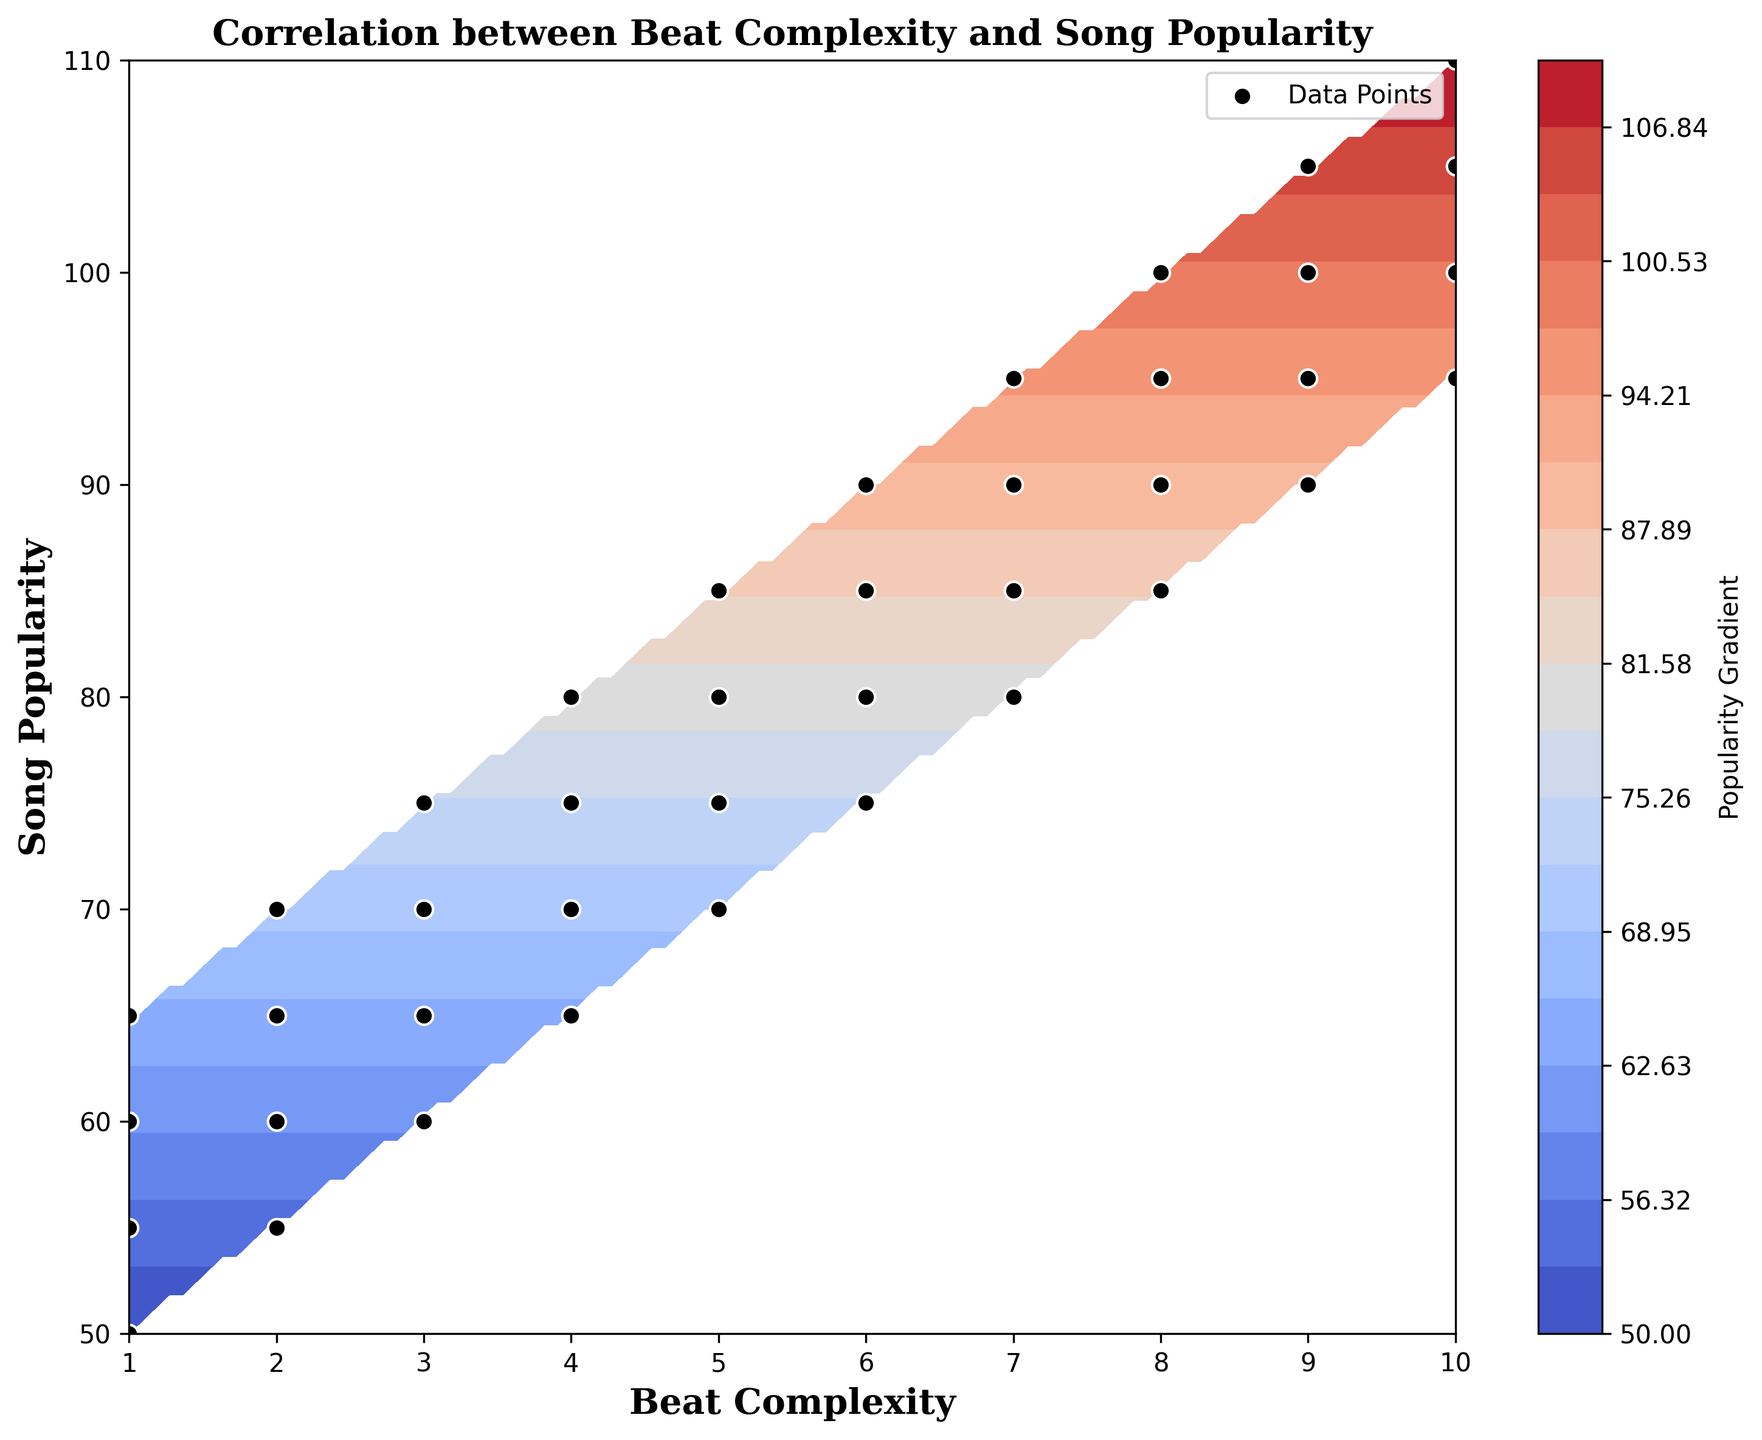What trend do you observe between beat complexity and song popularity? The contour plots show a clear gradient where as beat complexity increases, the song popularity also tends to increase. This indicates a positive correlation.
Answer: Positive correlation Where are the highest levels of song popularity found on the plot? The highest levels of song popularity, indicated by the darkest shades in the contour plot, are found at high beat complexity values, specifically around 9 and 10.
Answer: Around beat complexity of 9 and 10 Which beat complexity range exhibits the largest gradient change in song popularity? The largest gradient change in song popularity is observed between beat complexity of 8 and 10, where there is a steep shift in popularity scores.
Answer: Between beat complexity of 8 and 10 What is the beat complexity level at the lowest popularity range? The lowest popularity, around 50, is at the beat complexity level of 1.
Answer: Beat complexity of 1 Compare the popularity of songs with a beat complexity of 3 to those with a beat complexity of 6. Songs with a beat complexity of 3 have popularity ranging from 60 to 75, whereas those with a beat complexity of 6 range from 75 to 90. Thus, higher beat complexity has higher popularity.
Answer: Beat complexity of 6 is higher At which beat complexity does the song popularity start to exceed 80? Song popularity starts to exceed 80 at a beat complexity level of 7.
Answer: Beat complexity of 7 Are there any beat complexity levels where song popularity shows a dip? There is no observable dip in the song popularity across any beat complexity levels; the trend consistently increases.
Answer: No dips What does the color gradient indicate about the relationship between beat complexity and popularity? The color gradient, shifting from lighter to darker hues, indicates that as beat complexity increases, the song popularity tends to rise. The darker areas represent higher popularity.
Answer: Higher beat complexity, higher popularity Which beat complexity levels have data points representing the highest recorded popularity? Data points showing the highest recorded popularity are found at beat complexity levels of 8, 9, and 10.
Answer: Beat complexity 8, 9, 10 What can you say about the distribution of song popularity for beat complexity 5? For beat complexity 5, song popularity varies between 70 and 85, suggesting a moderate to high popularity range for these beats.
Answer: Range between 70 and 85 